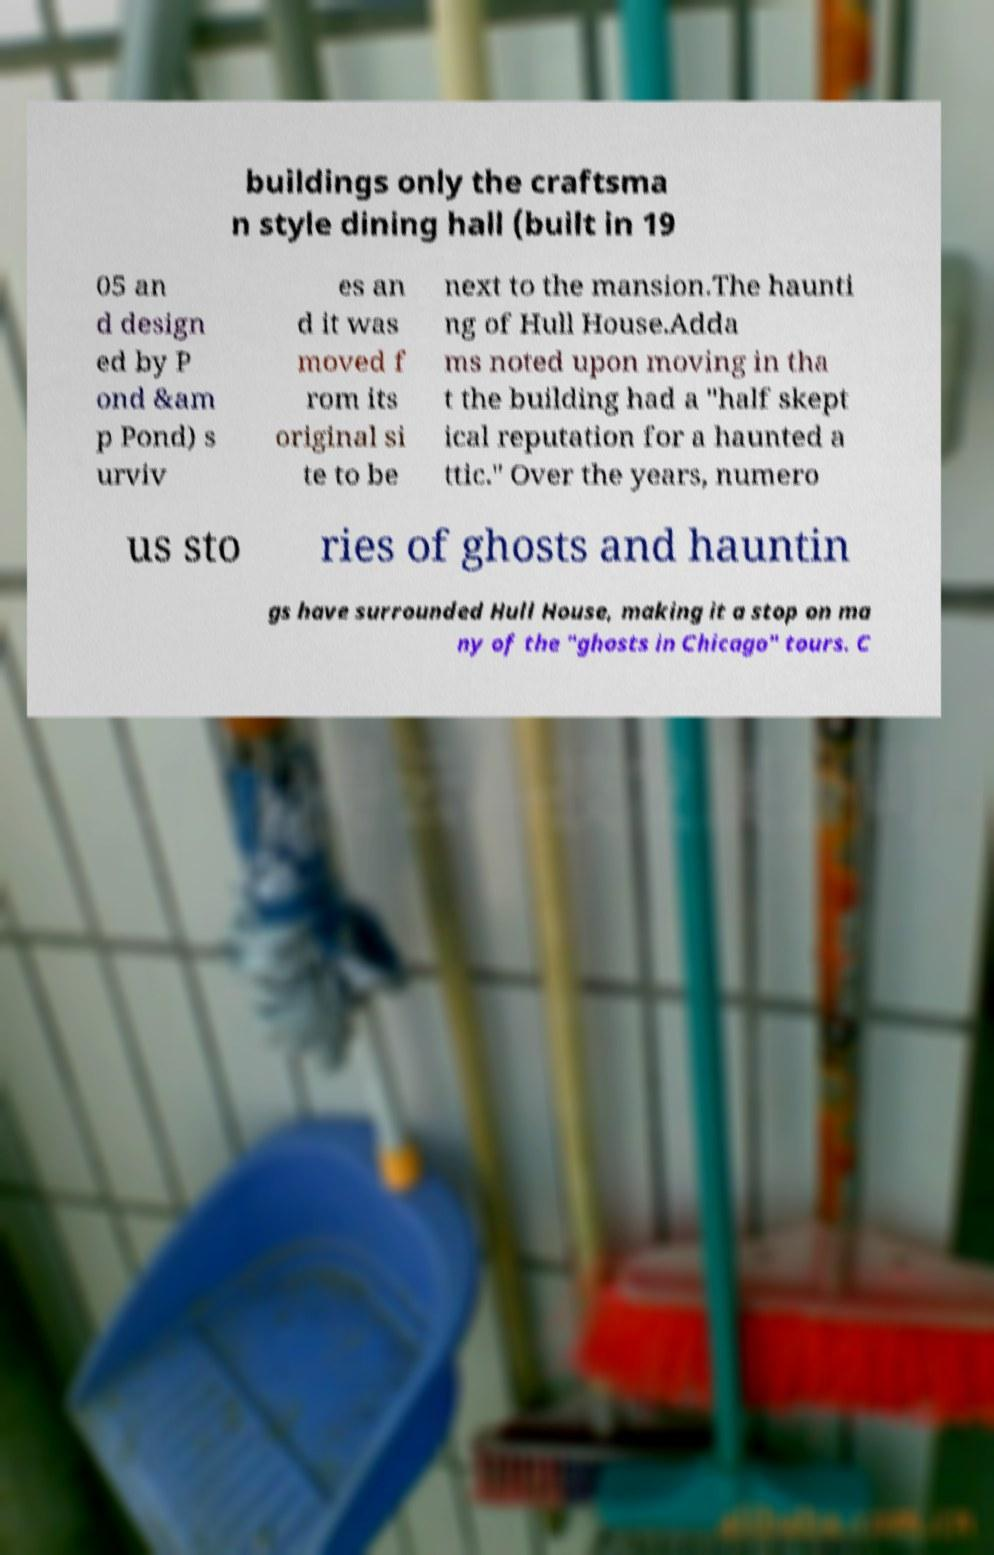There's text embedded in this image that I need extracted. Can you transcribe it verbatim? buildings only the craftsma n style dining hall (built in 19 05 an d design ed by P ond &am p Pond) s urviv es an d it was moved f rom its original si te to be next to the mansion.The haunti ng of Hull House.Adda ms noted upon moving in tha t the building had a "half skept ical reputation for a haunted a ttic." Over the years, numero us sto ries of ghosts and hauntin gs have surrounded Hull House, making it a stop on ma ny of the "ghosts in Chicago" tours. C 